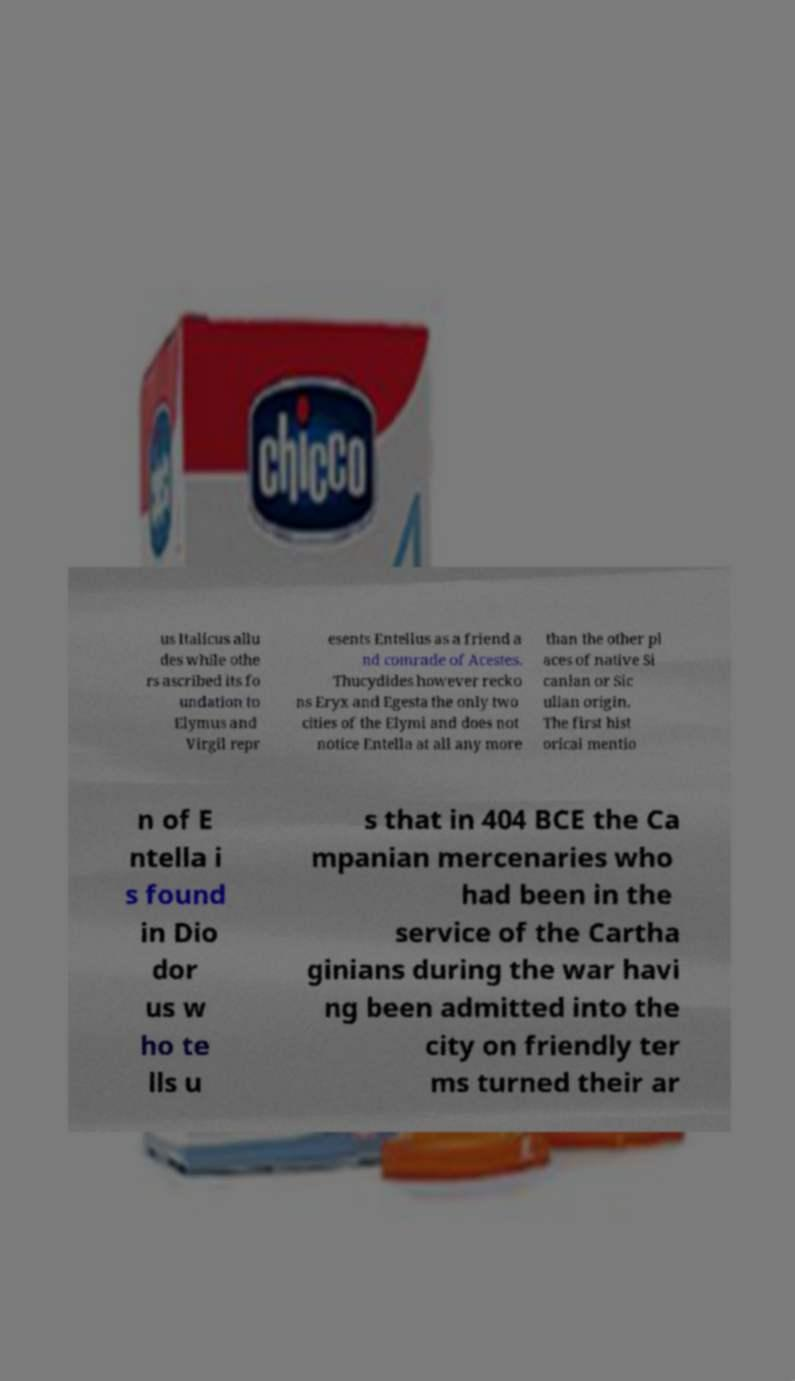Please identify and transcribe the text found in this image. us Italicus allu des while othe rs ascribed its fo undation to Elymus and Virgil repr esents Entellus as a friend a nd comrade of Acestes. Thucydides however recko ns Eryx and Egesta the only two cities of the Elymi and does not notice Entella at all any more than the other pl aces of native Si canian or Sic ulian origin. The first hist orical mentio n of E ntella i s found in Dio dor us w ho te lls u s that in 404 BCE the Ca mpanian mercenaries who had been in the service of the Cartha ginians during the war havi ng been admitted into the city on friendly ter ms turned their ar 